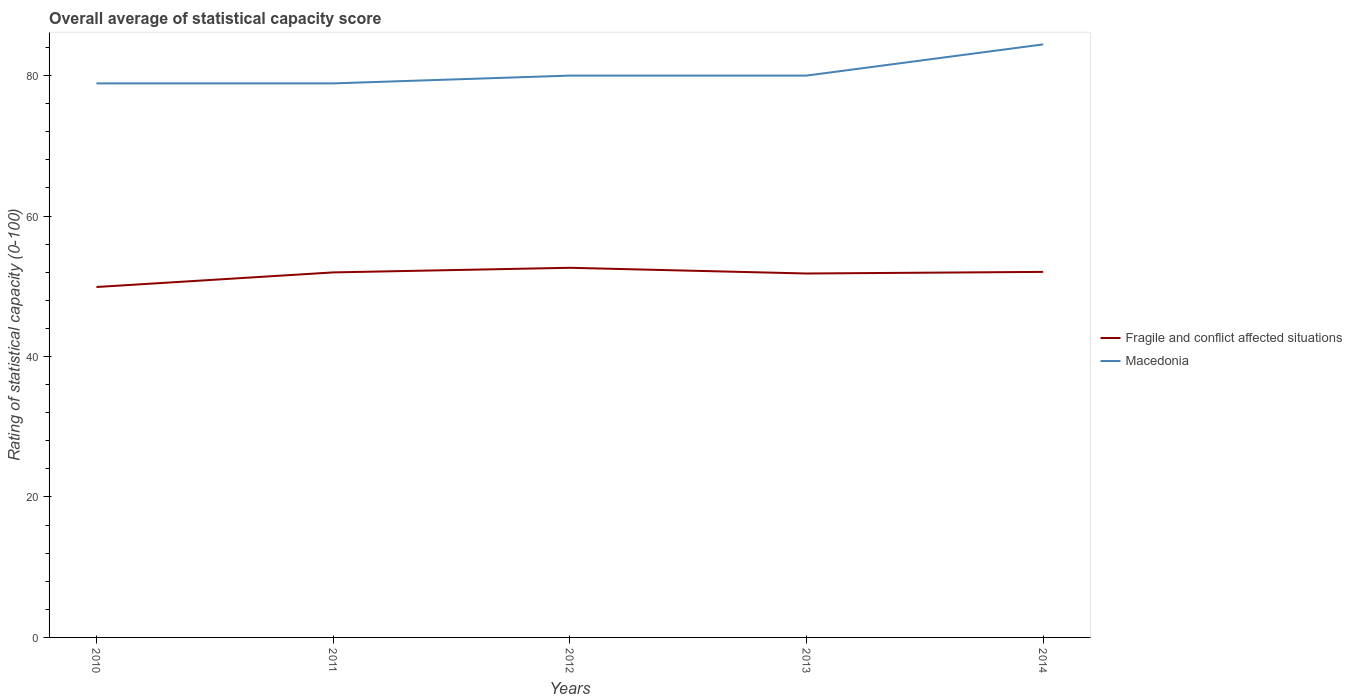Does the line corresponding to Fragile and conflict affected situations intersect with the line corresponding to Macedonia?
Your answer should be compact. No. Is the number of lines equal to the number of legend labels?
Keep it short and to the point. Yes. Across all years, what is the maximum rating of statistical capacity in Fragile and conflict affected situations?
Give a very brief answer. 49.9. What is the total rating of statistical capacity in Macedonia in the graph?
Give a very brief answer. 0. What is the difference between the highest and the second highest rating of statistical capacity in Fragile and conflict affected situations?
Give a very brief answer. 2.74. What is the difference between the highest and the lowest rating of statistical capacity in Fragile and conflict affected situations?
Keep it short and to the point. 4. How many lines are there?
Ensure brevity in your answer.  2. Are the values on the major ticks of Y-axis written in scientific E-notation?
Ensure brevity in your answer.  No. Does the graph contain any zero values?
Ensure brevity in your answer.  No. Where does the legend appear in the graph?
Provide a succinct answer. Center right. How are the legend labels stacked?
Make the answer very short. Vertical. What is the title of the graph?
Your answer should be very brief. Overall average of statistical capacity score. What is the label or title of the X-axis?
Your response must be concise. Years. What is the label or title of the Y-axis?
Your answer should be very brief. Rating of statistical capacity (0-100). What is the Rating of statistical capacity (0-100) of Fragile and conflict affected situations in 2010?
Offer a very short reply. 49.9. What is the Rating of statistical capacity (0-100) in Macedonia in 2010?
Offer a very short reply. 78.89. What is the Rating of statistical capacity (0-100) of Fragile and conflict affected situations in 2011?
Your response must be concise. 51.98. What is the Rating of statistical capacity (0-100) in Macedonia in 2011?
Your answer should be very brief. 78.89. What is the Rating of statistical capacity (0-100) in Fragile and conflict affected situations in 2012?
Ensure brevity in your answer.  52.63. What is the Rating of statistical capacity (0-100) in Macedonia in 2012?
Give a very brief answer. 80. What is the Rating of statistical capacity (0-100) in Fragile and conflict affected situations in 2013?
Keep it short and to the point. 51.82. What is the Rating of statistical capacity (0-100) of Macedonia in 2013?
Give a very brief answer. 80. What is the Rating of statistical capacity (0-100) of Fragile and conflict affected situations in 2014?
Keep it short and to the point. 52.05. What is the Rating of statistical capacity (0-100) in Macedonia in 2014?
Keep it short and to the point. 84.44. Across all years, what is the maximum Rating of statistical capacity (0-100) of Fragile and conflict affected situations?
Offer a very short reply. 52.63. Across all years, what is the maximum Rating of statistical capacity (0-100) of Macedonia?
Your answer should be very brief. 84.44. Across all years, what is the minimum Rating of statistical capacity (0-100) in Fragile and conflict affected situations?
Offer a terse response. 49.9. Across all years, what is the minimum Rating of statistical capacity (0-100) in Macedonia?
Your answer should be very brief. 78.89. What is the total Rating of statistical capacity (0-100) of Fragile and conflict affected situations in the graph?
Your answer should be compact. 258.38. What is the total Rating of statistical capacity (0-100) of Macedonia in the graph?
Your answer should be compact. 402.22. What is the difference between the Rating of statistical capacity (0-100) in Fragile and conflict affected situations in 2010 and that in 2011?
Your answer should be very brief. -2.08. What is the difference between the Rating of statistical capacity (0-100) in Macedonia in 2010 and that in 2011?
Keep it short and to the point. 0. What is the difference between the Rating of statistical capacity (0-100) of Fragile and conflict affected situations in 2010 and that in 2012?
Offer a very short reply. -2.74. What is the difference between the Rating of statistical capacity (0-100) in Macedonia in 2010 and that in 2012?
Provide a short and direct response. -1.11. What is the difference between the Rating of statistical capacity (0-100) in Fragile and conflict affected situations in 2010 and that in 2013?
Offer a very short reply. -1.92. What is the difference between the Rating of statistical capacity (0-100) in Macedonia in 2010 and that in 2013?
Your answer should be compact. -1.11. What is the difference between the Rating of statistical capacity (0-100) in Fragile and conflict affected situations in 2010 and that in 2014?
Make the answer very short. -2.15. What is the difference between the Rating of statistical capacity (0-100) of Macedonia in 2010 and that in 2014?
Offer a terse response. -5.56. What is the difference between the Rating of statistical capacity (0-100) in Fragile and conflict affected situations in 2011 and that in 2012?
Your response must be concise. -0.66. What is the difference between the Rating of statistical capacity (0-100) in Macedonia in 2011 and that in 2012?
Offer a very short reply. -1.11. What is the difference between the Rating of statistical capacity (0-100) of Fragile and conflict affected situations in 2011 and that in 2013?
Offer a terse response. 0.16. What is the difference between the Rating of statistical capacity (0-100) of Macedonia in 2011 and that in 2013?
Ensure brevity in your answer.  -1.11. What is the difference between the Rating of statistical capacity (0-100) of Fragile and conflict affected situations in 2011 and that in 2014?
Keep it short and to the point. -0.07. What is the difference between the Rating of statistical capacity (0-100) of Macedonia in 2011 and that in 2014?
Provide a succinct answer. -5.56. What is the difference between the Rating of statistical capacity (0-100) in Fragile and conflict affected situations in 2012 and that in 2013?
Ensure brevity in your answer.  0.81. What is the difference between the Rating of statistical capacity (0-100) of Macedonia in 2012 and that in 2013?
Provide a short and direct response. 0. What is the difference between the Rating of statistical capacity (0-100) in Fragile and conflict affected situations in 2012 and that in 2014?
Ensure brevity in your answer.  0.58. What is the difference between the Rating of statistical capacity (0-100) of Macedonia in 2012 and that in 2014?
Your response must be concise. -4.44. What is the difference between the Rating of statistical capacity (0-100) of Fragile and conflict affected situations in 2013 and that in 2014?
Provide a succinct answer. -0.23. What is the difference between the Rating of statistical capacity (0-100) of Macedonia in 2013 and that in 2014?
Offer a very short reply. -4.44. What is the difference between the Rating of statistical capacity (0-100) in Fragile and conflict affected situations in 2010 and the Rating of statistical capacity (0-100) in Macedonia in 2011?
Your answer should be very brief. -28.99. What is the difference between the Rating of statistical capacity (0-100) of Fragile and conflict affected situations in 2010 and the Rating of statistical capacity (0-100) of Macedonia in 2012?
Your answer should be compact. -30.1. What is the difference between the Rating of statistical capacity (0-100) of Fragile and conflict affected situations in 2010 and the Rating of statistical capacity (0-100) of Macedonia in 2013?
Provide a short and direct response. -30.1. What is the difference between the Rating of statistical capacity (0-100) of Fragile and conflict affected situations in 2010 and the Rating of statistical capacity (0-100) of Macedonia in 2014?
Your answer should be very brief. -34.55. What is the difference between the Rating of statistical capacity (0-100) in Fragile and conflict affected situations in 2011 and the Rating of statistical capacity (0-100) in Macedonia in 2012?
Offer a terse response. -28.02. What is the difference between the Rating of statistical capacity (0-100) of Fragile and conflict affected situations in 2011 and the Rating of statistical capacity (0-100) of Macedonia in 2013?
Keep it short and to the point. -28.02. What is the difference between the Rating of statistical capacity (0-100) in Fragile and conflict affected situations in 2011 and the Rating of statistical capacity (0-100) in Macedonia in 2014?
Offer a terse response. -32.47. What is the difference between the Rating of statistical capacity (0-100) of Fragile and conflict affected situations in 2012 and the Rating of statistical capacity (0-100) of Macedonia in 2013?
Provide a short and direct response. -27.37. What is the difference between the Rating of statistical capacity (0-100) in Fragile and conflict affected situations in 2012 and the Rating of statistical capacity (0-100) in Macedonia in 2014?
Ensure brevity in your answer.  -31.81. What is the difference between the Rating of statistical capacity (0-100) of Fragile and conflict affected situations in 2013 and the Rating of statistical capacity (0-100) of Macedonia in 2014?
Provide a succinct answer. -32.62. What is the average Rating of statistical capacity (0-100) in Fragile and conflict affected situations per year?
Your answer should be very brief. 51.68. What is the average Rating of statistical capacity (0-100) in Macedonia per year?
Your answer should be compact. 80.44. In the year 2010, what is the difference between the Rating of statistical capacity (0-100) of Fragile and conflict affected situations and Rating of statistical capacity (0-100) of Macedonia?
Offer a terse response. -28.99. In the year 2011, what is the difference between the Rating of statistical capacity (0-100) in Fragile and conflict affected situations and Rating of statistical capacity (0-100) in Macedonia?
Provide a succinct answer. -26.91. In the year 2012, what is the difference between the Rating of statistical capacity (0-100) in Fragile and conflict affected situations and Rating of statistical capacity (0-100) in Macedonia?
Your answer should be compact. -27.37. In the year 2013, what is the difference between the Rating of statistical capacity (0-100) in Fragile and conflict affected situations and Rating of statistical capacity (0-100) in Macedonia?
Offer a very short reply. -28.18. In the year 2014, what is the difference between the Rating of statistical capacity (0-100) of Fragile and conflict affected situations and Rating of statistical capacity (0-100) of Macedonia?
Ensure brevity in your answer.  -32.39. What is the ratio of the Rating of statistical capacity (0-100) of Fragile and conflict affected situations in 2010 to that in 2012?
Make the answer very short. 0.95. What is the ratio of the Rating of statistical capacity (0-100) of Macedonia in 2010 to that in 2012?
Ensure brevity in your answer.  0.99. What is the ratio of the Rating of statistical capacity (0-100) in Fragile and conflict affected situations in 2010 to that in 2013?
Offer a terse response. 0.96. What is the ratio of the Rating of statistical capacity (0-100) in Macedonia in 2010 to that in 2013?
Offer a terse response. 0.99. What is the ratio of the Rating of statistical capacity (0-100) in Fragile and conflict affected situations in 2010 to that in 2014?
Your response must be concise. 0.96. What is the ratio of the Rating of statistical capacity (0-100) of Macedonia in 2010 to that in 2014?
Your answer should be very brief. 0.93. What is the ratio of the Rating of statistical capacity (0-100) of Fragile and conflict affected situations in 2011 to that in 2012?
Keep it short and to the point. 0.99. What is the ratio of the Rating of statistical capacity (0-100) in Macedonia in 2011 to that in 2012?
Provide a succinct answer. 0.99. What is the ratio of the Rating of statistical capacity (0-100) in Fragile and conflict affected situations in 2011 to that in 2013?
Keep it short and to the point. 1. What is the ratio of the Rating of statistical capacity (0-100) in Macedonia in 2011 to that in 2013?
Offer a terse response. 0.99. What is the ratio of the Rating of statistical capacity (0-100) in Fragile and conflict affected situations in 2011 to that in 2014?
Provide a succinct answer. 1. What is the ratio of the Rating of statistical capacity (0-100) of Macedonia in 2011 to that in 2014?
Provide a succinct answer. 0.93. What is the ratio of the Rating of statistical capacity (0-100) in Fragile and conflict affected situations in 2012 to that in 2013?
Make the answer very short. 1.02. What is the ratio of the Rating of statistical capacity (0-100) of Fragile and conflict affected situations in 2012 to that in 2014?
Your answer should be compact. 1.01. What is the ratio of the Rating of statistical capacity (0-100) in Macedonia in 2012 to that in 2014?
Offer a very short reply. 0.95. What is the ratio of the Rating of statistical capacity (0-100) in Fragile and conflict affected situations in 2013 to that in 2014?
Provide a short and direct response. 1. What is the ratio of the Rating of statistical capacity (0-100) in Macedonia in 2013 to that in 2014?
Make the answer very short. 0.95. What is the difference between the highest and the second highest Rating of statistical capacity (0-100) of Fragile and conflict affected situations?
Offer a terse response. 0.58. What is the difference between the highest and the second highest Rating of statistical capacity (0-100) of Macedonia?
Offer a terse response. 4.44. What is the difference between the highest and the lowest Rating of statistical capacity (0-100) in Fragile and conflict affected situations?
Give a very brief answer. 2.74. What is the difference between the highest and the lowest Rating of statistical capacity (0-100) in Macedonia?
Ensure brevity in your answer.  5.56. 